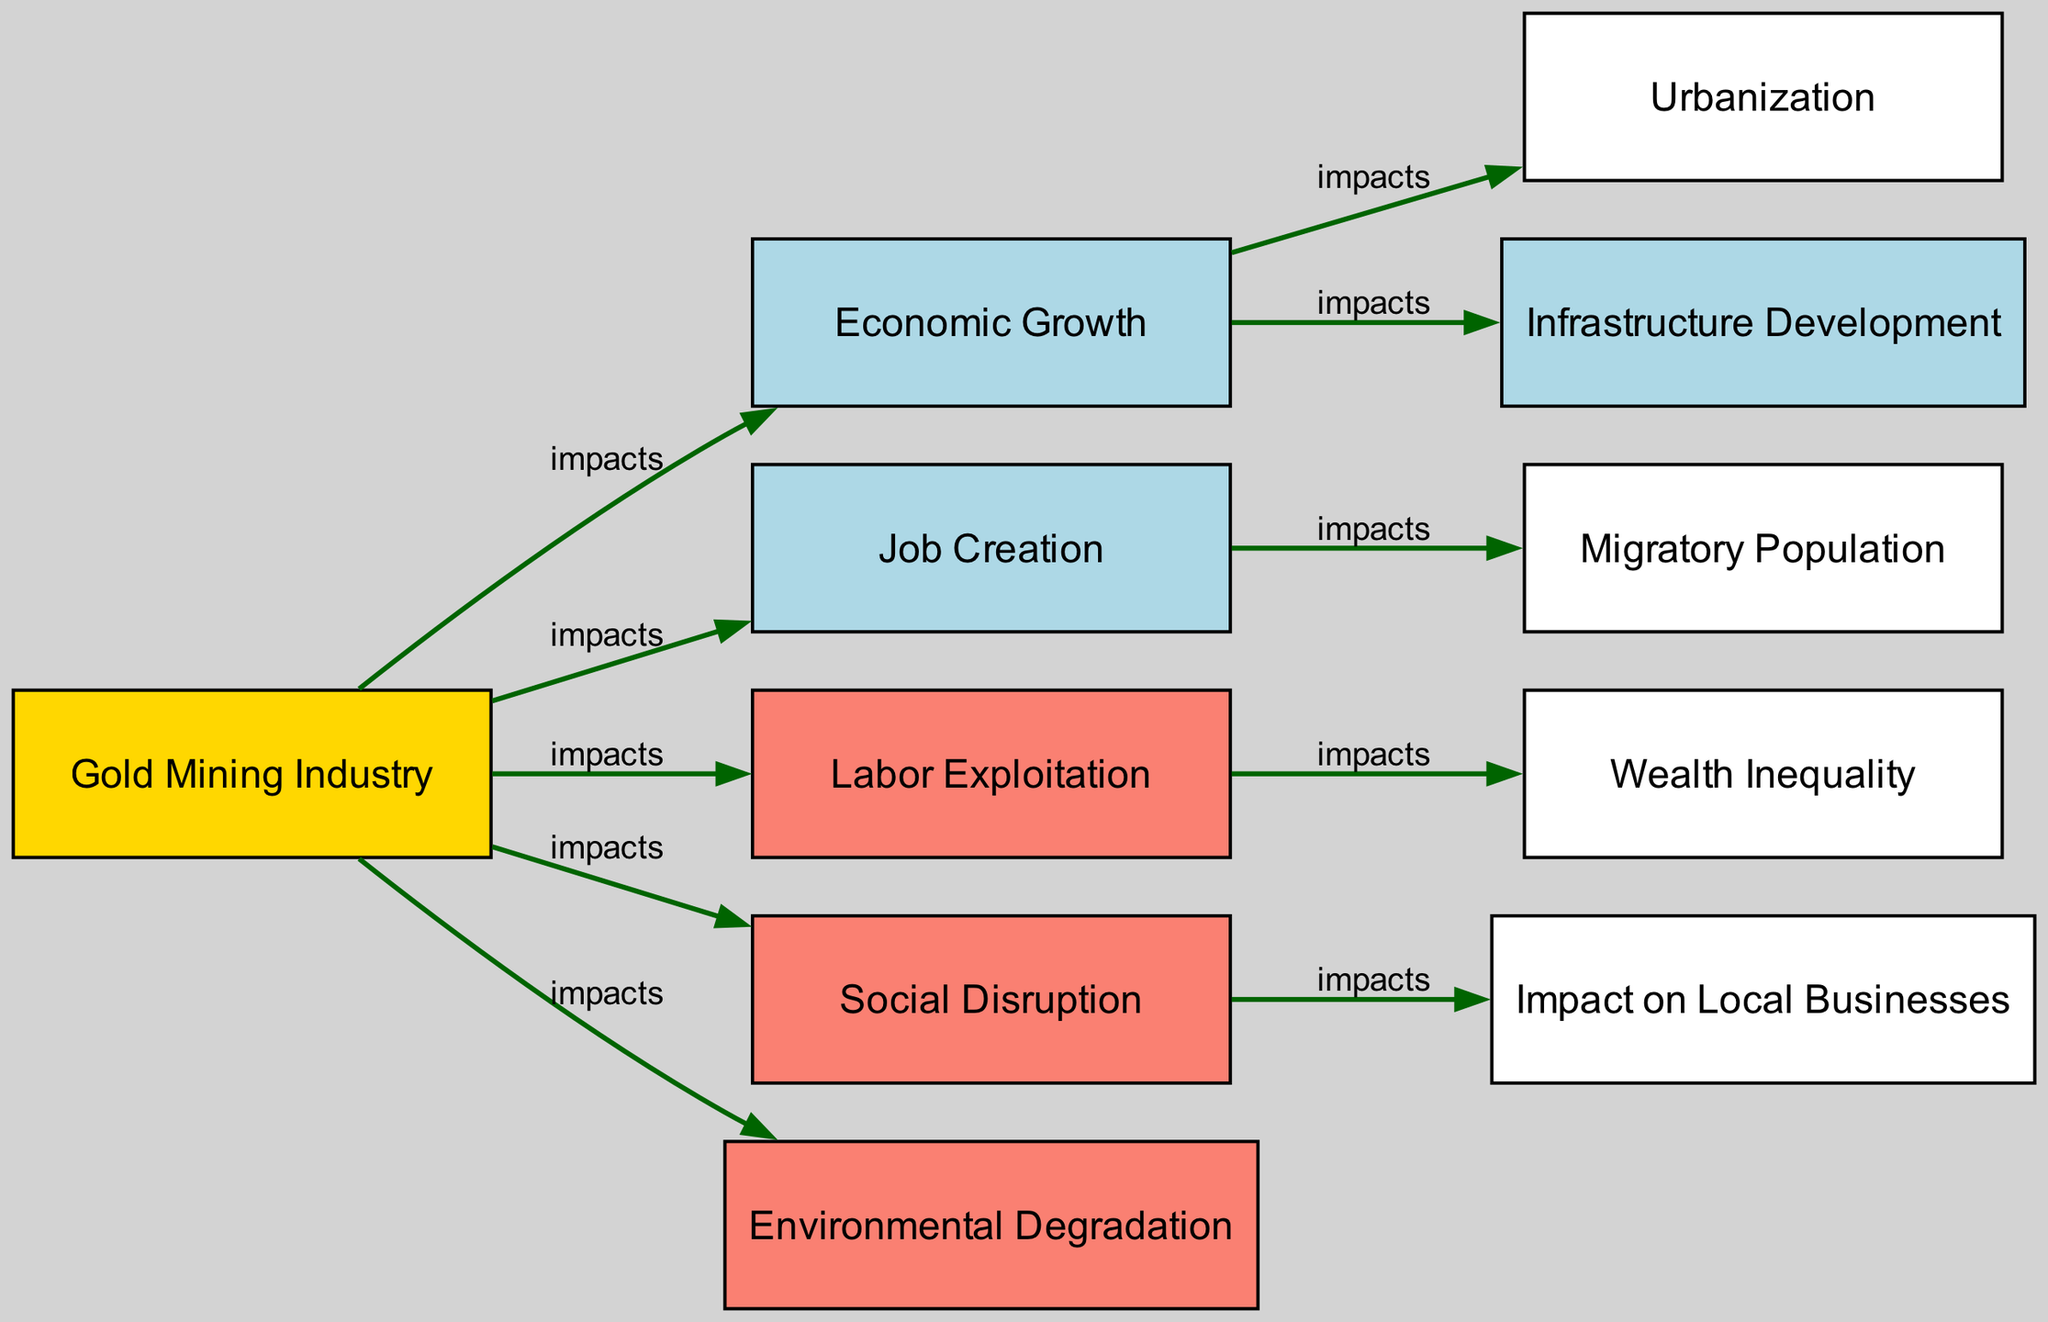What is the primary industry illustrated in this diagram? The diagram centers around the "Gold Mining Industry" as the main node, indicating its significance in the socio-economic impacts being depicted.
Answer: Gold Mining Industry How many nodes are there in the diagram? The diagram contains 11 nodes, which include all the distinct concepts related to the gold mining industry's socio-economic impacts and effects on local communities.
Answer: 11 Which node is affected by both "Labor Exploitation" and "Social Disruption"? "Local Business Impacts" is impacted by "Social Disruption," while "Labor Exploitation" leads to "Wealth Inequality." Both of these indicate how the mining industry causes broader challenges for local businesses due to these two impacts.
Answer: Local Business Impacts What does "Economic Growth" influence in the diagram? "Economic Growth" leads to both "Urbanization" and "Infrastructure Development," highlighting the direct benefits of growth generated by the gold mining industry on local communities.
Answer: Urbanization, Infrastructure Development What result follows from "Job Creation" in the context of this diagram? The "Job Creation" node is directly connected to "Migratory Population," suggesting that the job opportunities from mining attract people from other areas, resulting in population movements.
Answer: Migratory Population Which node represents a negative socio-economic impact of the gold mining industry? "Environmental Degradation" is shown in the diagram as a negative consequence resulting from the gold mining industry, indicating harm caused to the surroundings.
Answer: Environmental Degradation How does "Wealth Inequality" manifest in this context? "Wealth Inequality" is a consequence of "Labor Exploitation," which signifies that the benefits of mining are not evenly distributed among the local communities, leading to disparities in wealth.
Answer: Labor Exploitation What kind of impacts can we expect from "Gold Mining" on local businesses? "Gold Mining" causes "Social Disruption," which then directly affects "Local Business Impacts," indicating that social changes can hamper local economic activity.
Answer: Local Business Impacts Which node connects the impacts of "Economic Growth" to urban development? "Urbanization" is the direct result of "Economic Growth," showing the relationship between economic activities and increased urban development in the region.
Answer: Urbanization 